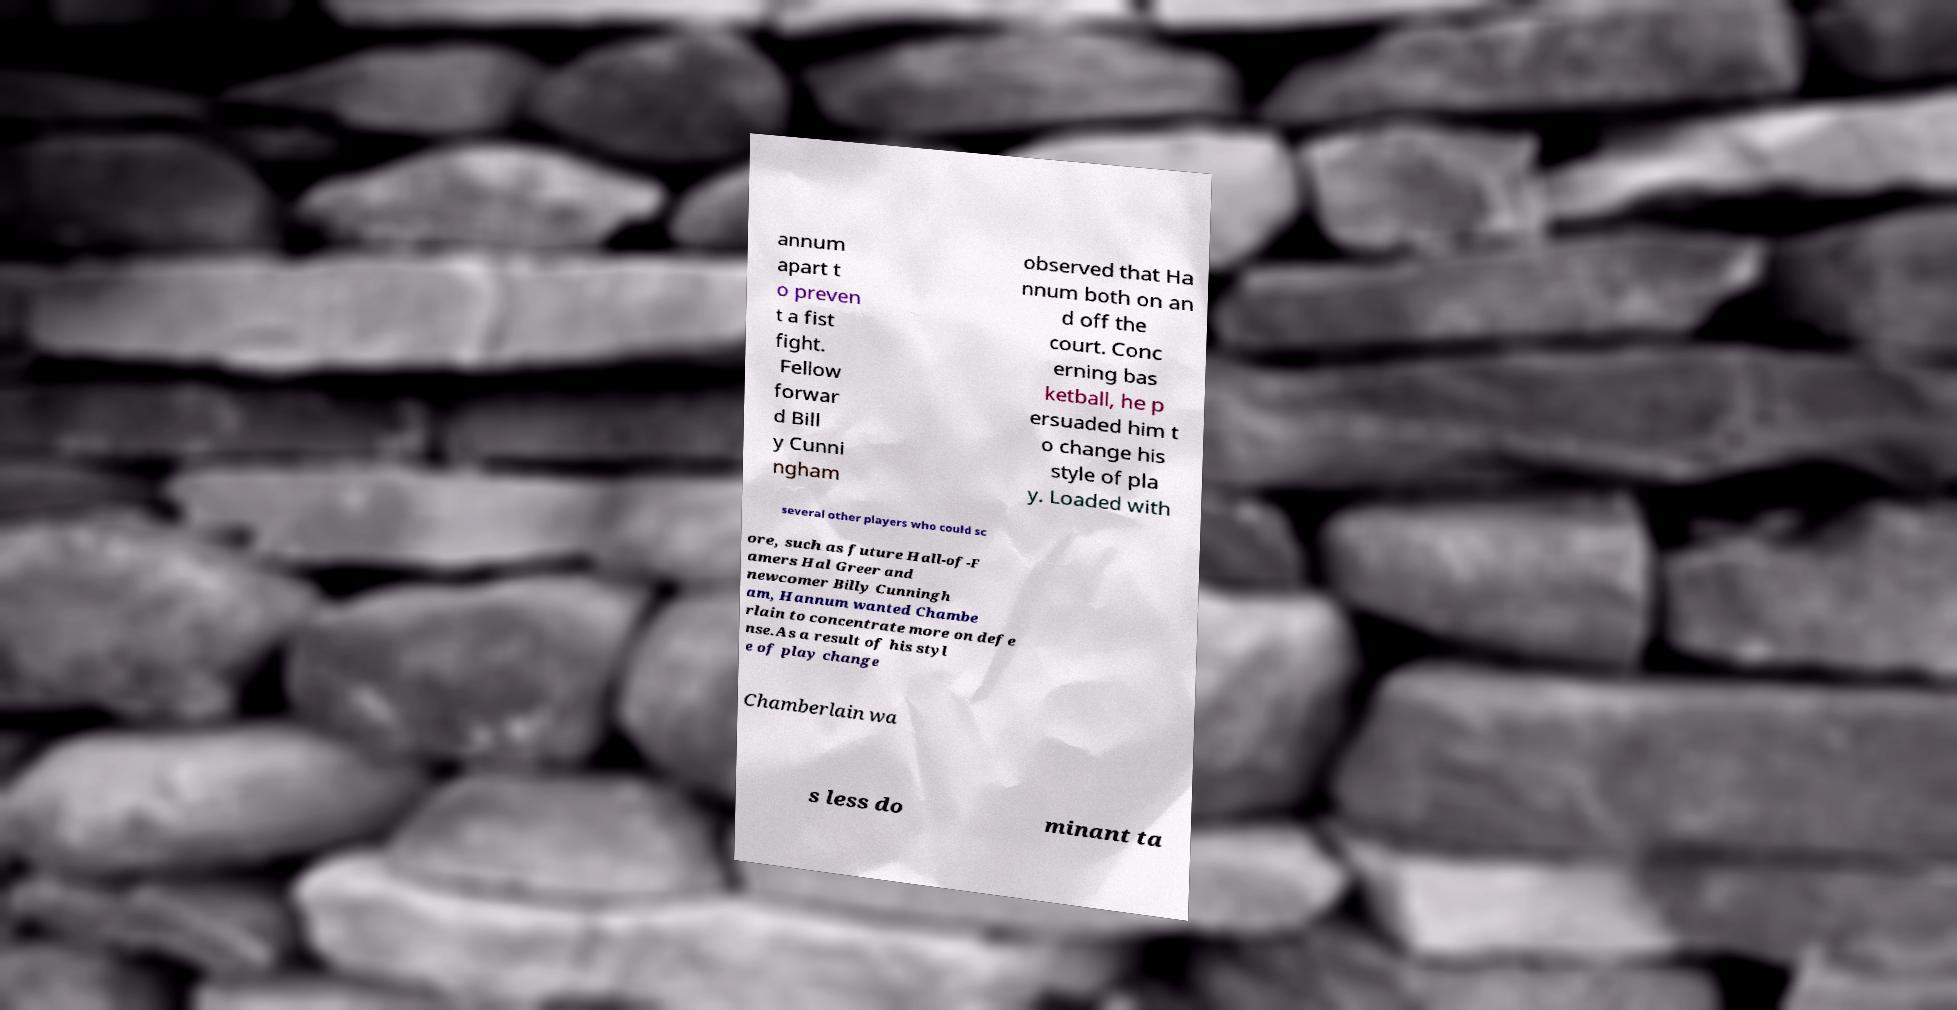Can you read and provide the text displayed in the image?This photo seems to have some interesting text. Can you extract and type it out for me? annum apart t o preven t a fist fight. Fellow forwar d Bill y Cunni ngham observed that Ha nnum both on an d off the court. Conc erning bas ketball, he p ersuaded him t o change his style of pla y. Loaded with several other players who could sc ore, such as future Hall-of-F amers Hal Greer and newcomer Billy Cunningh am, Hannum wanted Chambe rlain to concentrate more on defe nse.As a result of his styl e of play change Chamberlain wa s less do minant ta 